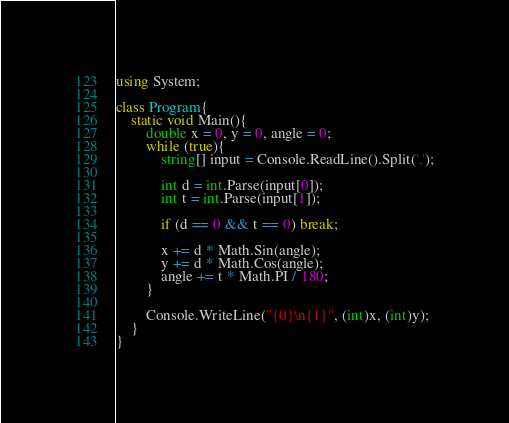Convert code to text. <code><loc_0><loc_0><loc_500><loc_500><_C#_>using System;

class Program{
	static void Main(){
		double x = 0, y = 0, angle = 0;
		while (true){
			string[] input = Console.ReadLine().Split(',');

			int d = int.Parse(input[0]);
			int t = int.Parse(input[1]);
			
			if (d == 0 && t == 0) break;
			
			x += d * Math.Sin(angle);
			y += d * Math.Cos(angle);
			angle += t * Math.PI / 180;
		}

		Console.WriteLine("{0}\n{1}", (int)x, (int)y);
    }
}</code> 